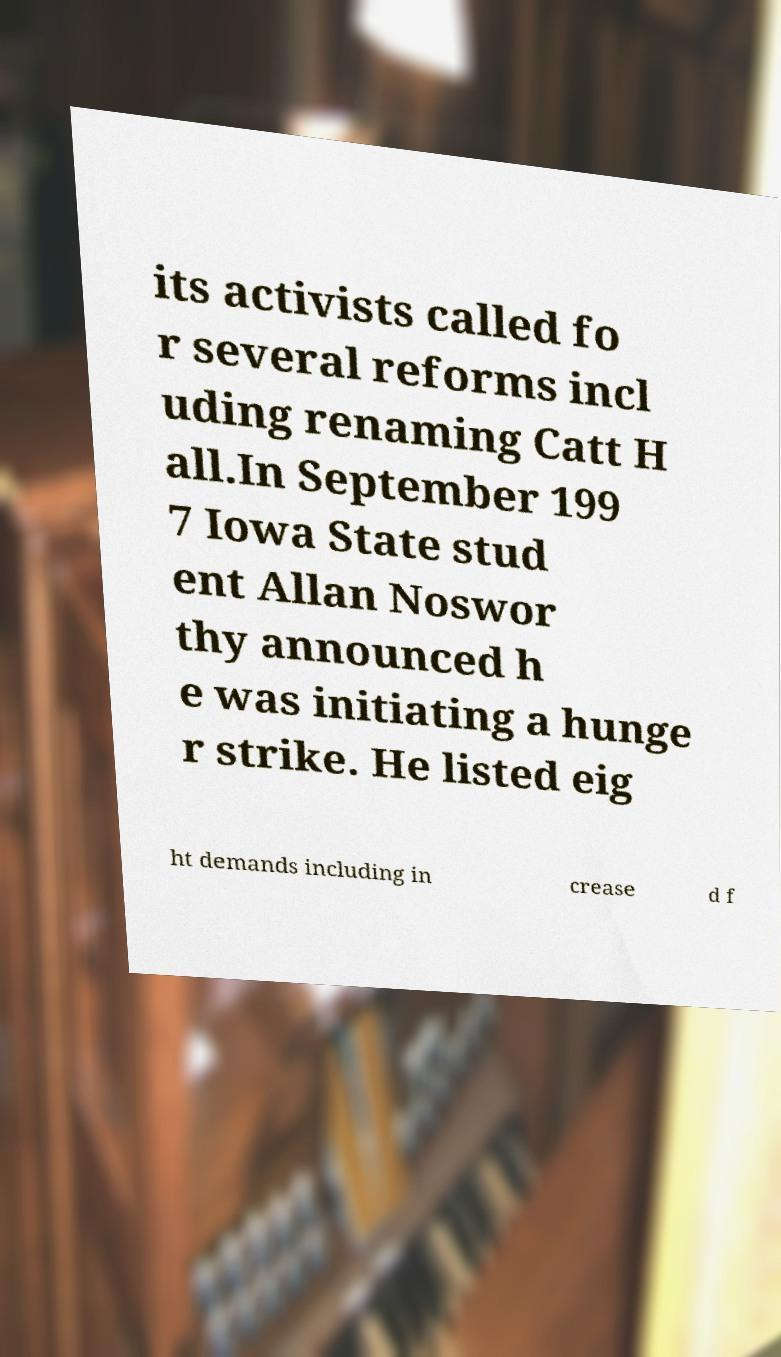Can you read and provide the text displayed in the image?This photo seems to have some interesting text. Can you extract and type it out for me? its activists called fo r several reforms incl uding renaming Catt H all.In September 199 7 Iowa State stud ent Allan Noswor thy announced h e was initiating a hunge r strike. He listed eig ht demands including in crease d f 